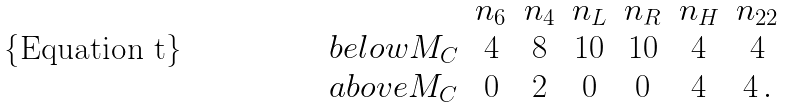Convert formula to latex. <formula><loc_0><loc_0><loc_500><loc_500>\begin{array} { l c c c c c c } & n _ { 6 } & n _ { 4 } & n _ { L } & n _ { R } & n _ { H } & n _ { 2 2 } \\ { b e l o w M _ { C } } & 4 & 8 & 1 0 & 1 0 & 4 & 4 \\ { a b o v e M _ { C } } & 0 & 2 & 0 & 0 & 4 & 4 \, . \end{array}</formula> 